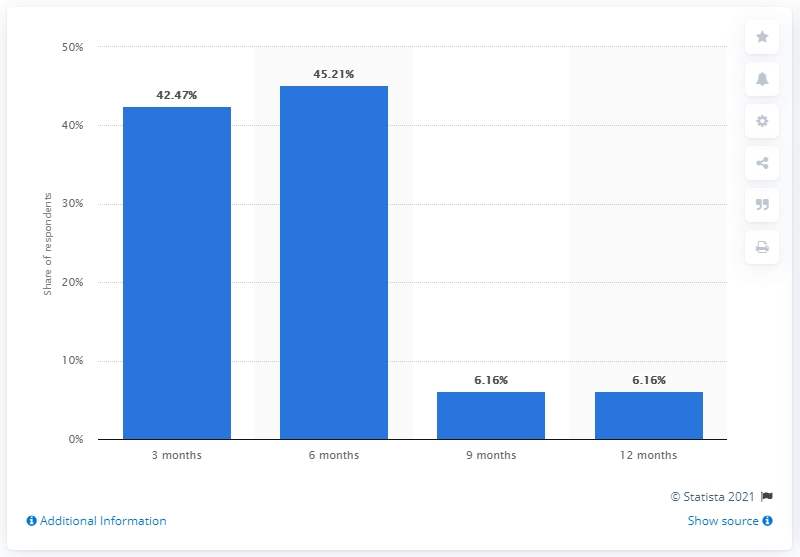Mention a couple of crucial points in this snapshot. According to the survey, 45.21% of respondents believed that the current situation would last for approximately six months. 